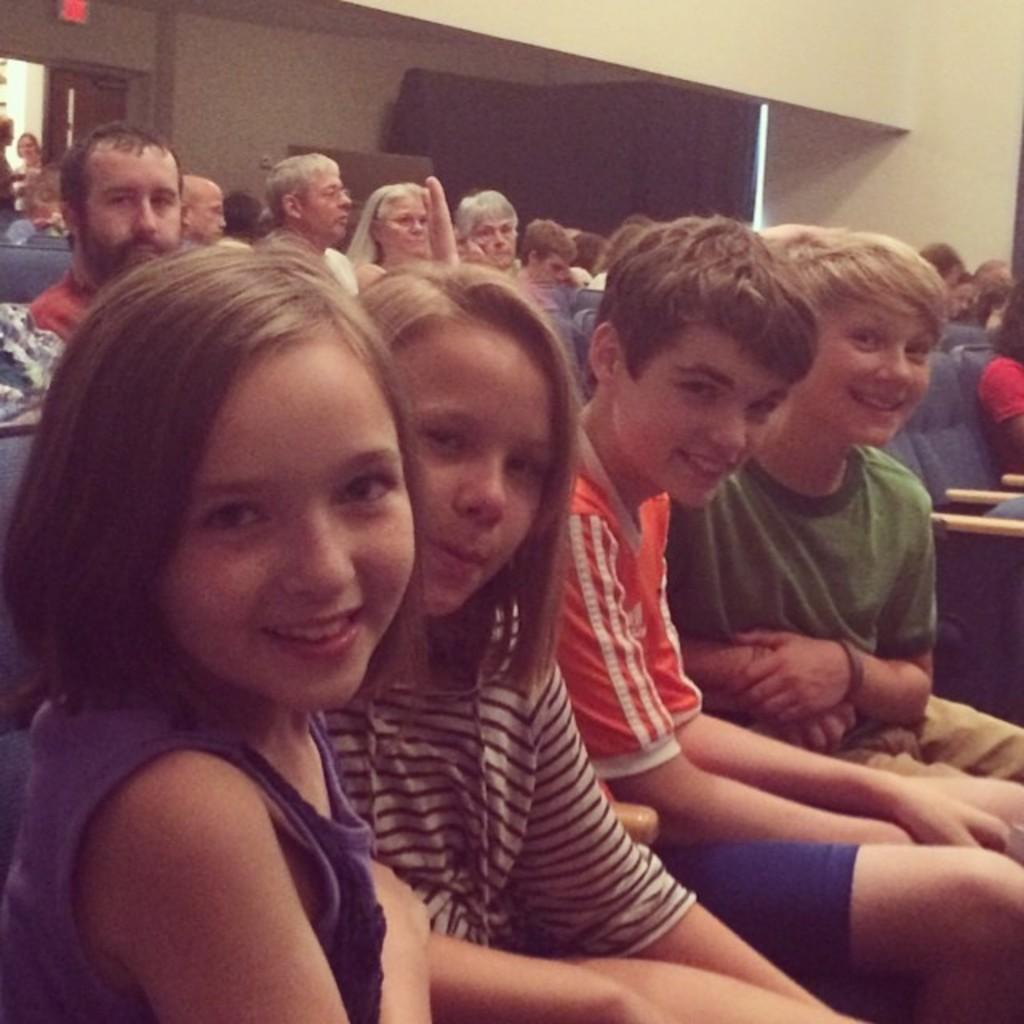What are the people in the image doing? There is a group of people sitting in the image. Can you describe the clothing of the person in front? The person in front is wearing a blue shirt. What can be seen in the background of the image? There are curtains visible in the background of the image, and the wall is white. Why is the person in the vest crying in the image? There is no person in a vest or anyone crying in the image. The person in front is wearing a blue shirt, and the image does not depict any emotional expressions. 